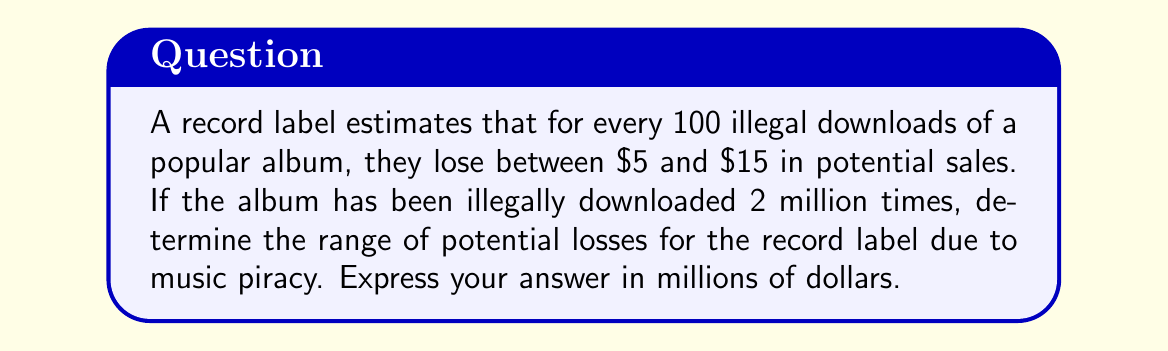Teach me how to tackle this problem. Let's approach this step-by-step:

1) First, we need to calculate the number of hundreds in 2 million downloads:
   $\frac{2,000,000}{100} = 20,000$

2) Now, we can set up our inequalities:
   Lower bound: $20,000 \times $5 = $100,000
   Upper bound: $20,000 \times $15 = $300,000

3) These amounts are in dollars, but we need to express them in millions of dollars:
   Lower bound: $\frac{$100,000}{$1,000,000} = $0.1$ million
   Upper bound: $\frac{$300,000}{$1,000,000} = $0.3$ million

4) Therefore, the range of potential losses can be expressed as an inequality:
   $$0.1 \leq x \leq 0.3$$
   where $x$ represents the potential losses in millions of dollars.
Answer: $[0.1, 0.3]$ million dollars 